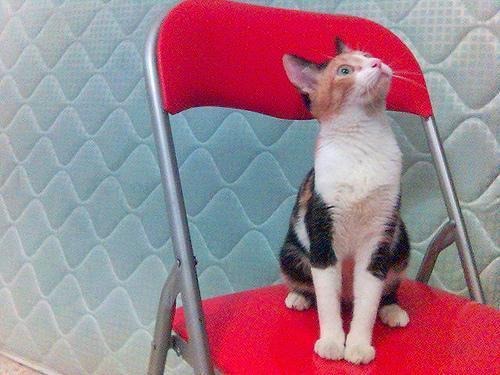How many men have a drink in their hand?
Give a very brief answer. 0. 